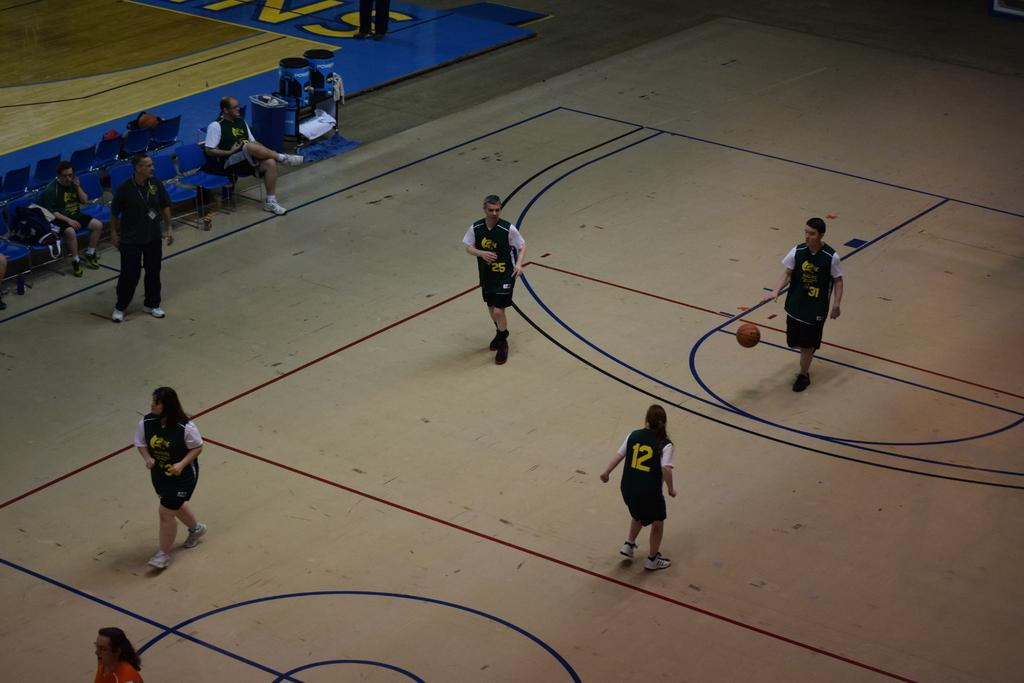Provide a one-sentence caption for the provided image. Number 12 playing defense on number 31 who is dribbling the ball. 